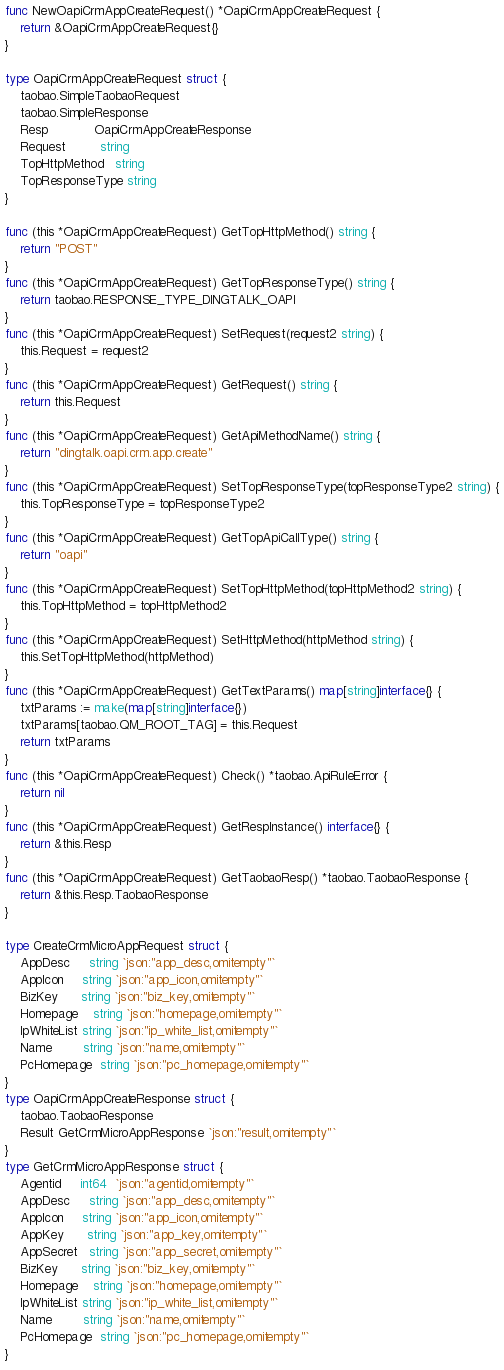<code> <loc_0><loc_0><loc_500><loc_500><_Go_>
func NewOapiCrmAppCreateRequest() *OapiCrmAppCreateRequest {
	return &OapiCrmAppCreateRequest{}
}

type OapiCrmAppCreateRequest struct {
	taobao.SimpleTaobaoRequest
	taobao.SimpleResponse
	Resp            OapiCrmAppCreateResponse
	Request         string
	TopHttpMethod   string
	TopResponseType string
}

func (this *OapiCrmAppCreateRequest) GetTopHttpMethod() string {
	return "POST"
}
func (this *OapiCrmAppCreateRequest) GetTopResponseType() string {
	return taobao.RESPONSE_TYPE_DINGTALK_OAPI
}
func (this *OapiCrmAppCreateRequest) SetRequest(request2 string) {
	this.Request = request2
}
func (this *OapiCrmAppCreateRequest) GetRequest() string {
	return this.Request
}
func (this *OapiCrmAppCreateRequest) GetApiMethodName() string {
	return "dingtalk.oapi.crm.app.create"
}
func (this *OapiCrmAppCreateRequest) SetTopResponseType(topResponseType2 string) {
	this.TopResponseType = topResponseType2
}
func (this *OapiCrmAppCreateRequest) GetTopApiCallType() string {
	return "oapi"
}
func (this *OapiCrmAppCreateRequest) SetTopHttpMethod(topHttpMethod2 string) {
	this.TopHttpMethod = topHttpMethod2
}
func (this *OapiCrmAppCreateRequest) SetHttpMethod(httpMethod string) {
	this.SetTopHttpMethod(httpMethod)
}
func (this *OapiCrmAppCreateRequest) GetTextParams() map[string]interface{} {
	txtParams := make(map[string]interface{})
	txtParams[taobao.QM_ROOT_TAG] = this.Request
	return txtParams
}
func (this *OapiCrmAppCreateRequest) Check() *taobao.ApiRuleError {
	return nil
}
func (this *OapiCrmAppCreateRequest) GetRespInstance() interface{} {
	return &this.Resp
}
func (this *OapiCrmAppCreateRequest) GetTaobaoResp() *taobao.TaobaoResponse {
	return &this.Resp.TaobaoResponse
}

type CreateCrmMicroAppRequest struct {
	AppDesc     string `json:"app_desc,omitempty"`
	AppIcon     string `json:"app_icon,omitempty"`
	BizKey      string `json:"biz_key,omitempty"`
	Homepage    string `json:"homepage,omitempty"`
	IpWhiteList string `json:"ip_white_list,omitempty"`
	Name        string `json:"name,omitempty"`
	PcHomepage  string `json:"pc_homepage,omitempty"`
}
type OapiCrmAppCreateResponse struct {
	taobao.TaobaoResponse
	Result GetCrmMicroAppResponse `json:"result,omitempty"`
}
type GetCrmMicroAppResponse struct {
	Agentid     int64  `json:"agentid,omitempty"`
	AppDesc     string `json:"app_desc,omitempty"`
	AppIcon     string `json:"app_icon,omitempty"`
	AppKey      string `json:"app_key,omitempty"`
	AppSecret   string `json:"app_secret,omitempty"`
	BizKey      string `json:"biz_key,omitempty"`
	Homepage    string `json:"homepage,omitempty"`
	IpWhiteList string `json:"ip_white_list,omitempty"`
	Name        string `json:"name,omitempty"`
	PcHomepage  string `json:"pc_homepage,omitempty"`
}
</code> 